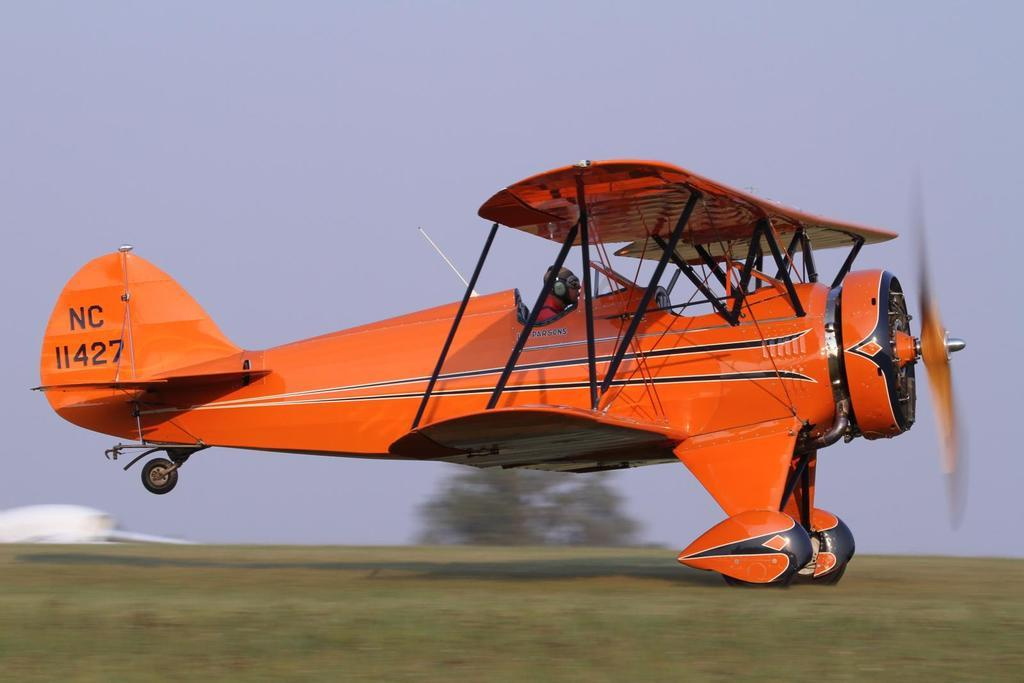Provide a one-sentence caption for the provided image. A small crop dusting plane is moving on the ground and has the call numbers NC11427. 